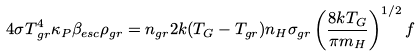<formula> <loc_0><loc_0><loc_500><loc_500>4 { \sigma } T { ^ { 4 } _ { g r } } { \kappa _ { P } } { \beta _ { e s c } } { \rho _ { g r } } = n { _ { g r } } 2 k ( T _ { G } - T _ { g r } ) n _ { H } { \sigma _ { g r } } \left ( \frac { 8 k T _ { G } } { { \pi } m _ { H } } \right ) ^ { 1 / 2 } f</formula> 